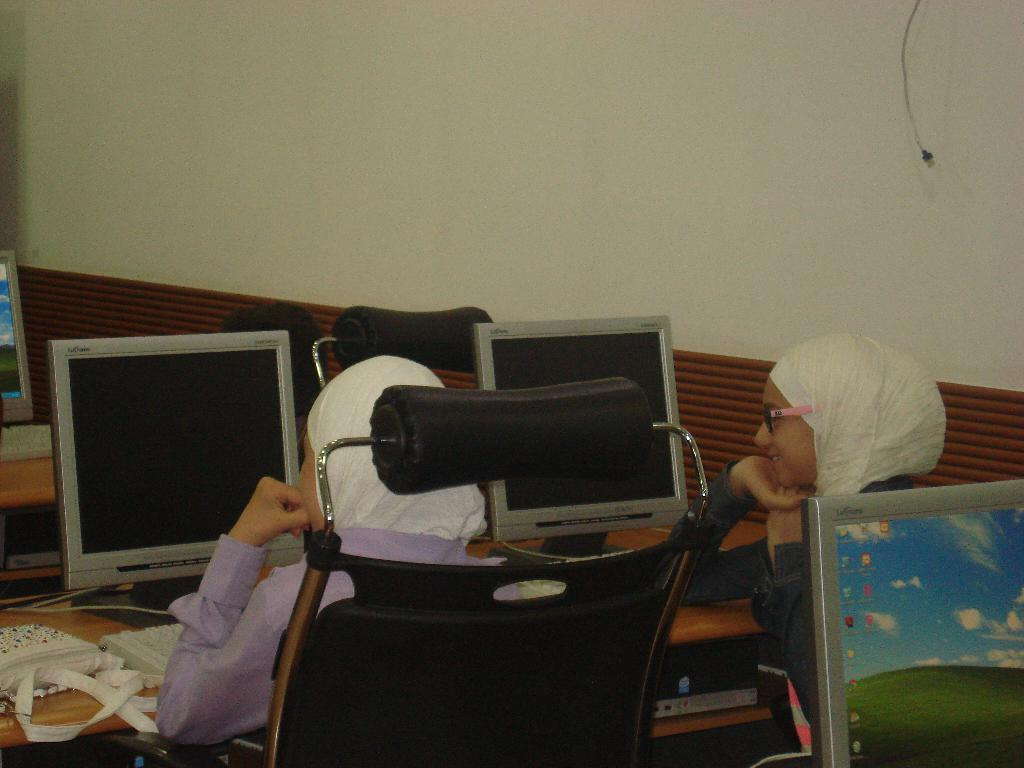How many people are in the room? There are two people in the room. What are the people doing in the room? The people are sitting on chairs. What furniture is present in the room? There is a table in the room. What electronic device is on the table? There is a computer system on the table. What is used to input data into the computer system? There is a keyboard associated with the computer system. What type of quince can be seen on the table? There is no quince present on the table in the image. How many toes are visible on the people in the room? The image does not show the people's toes, so it cannot be determined from the image. 